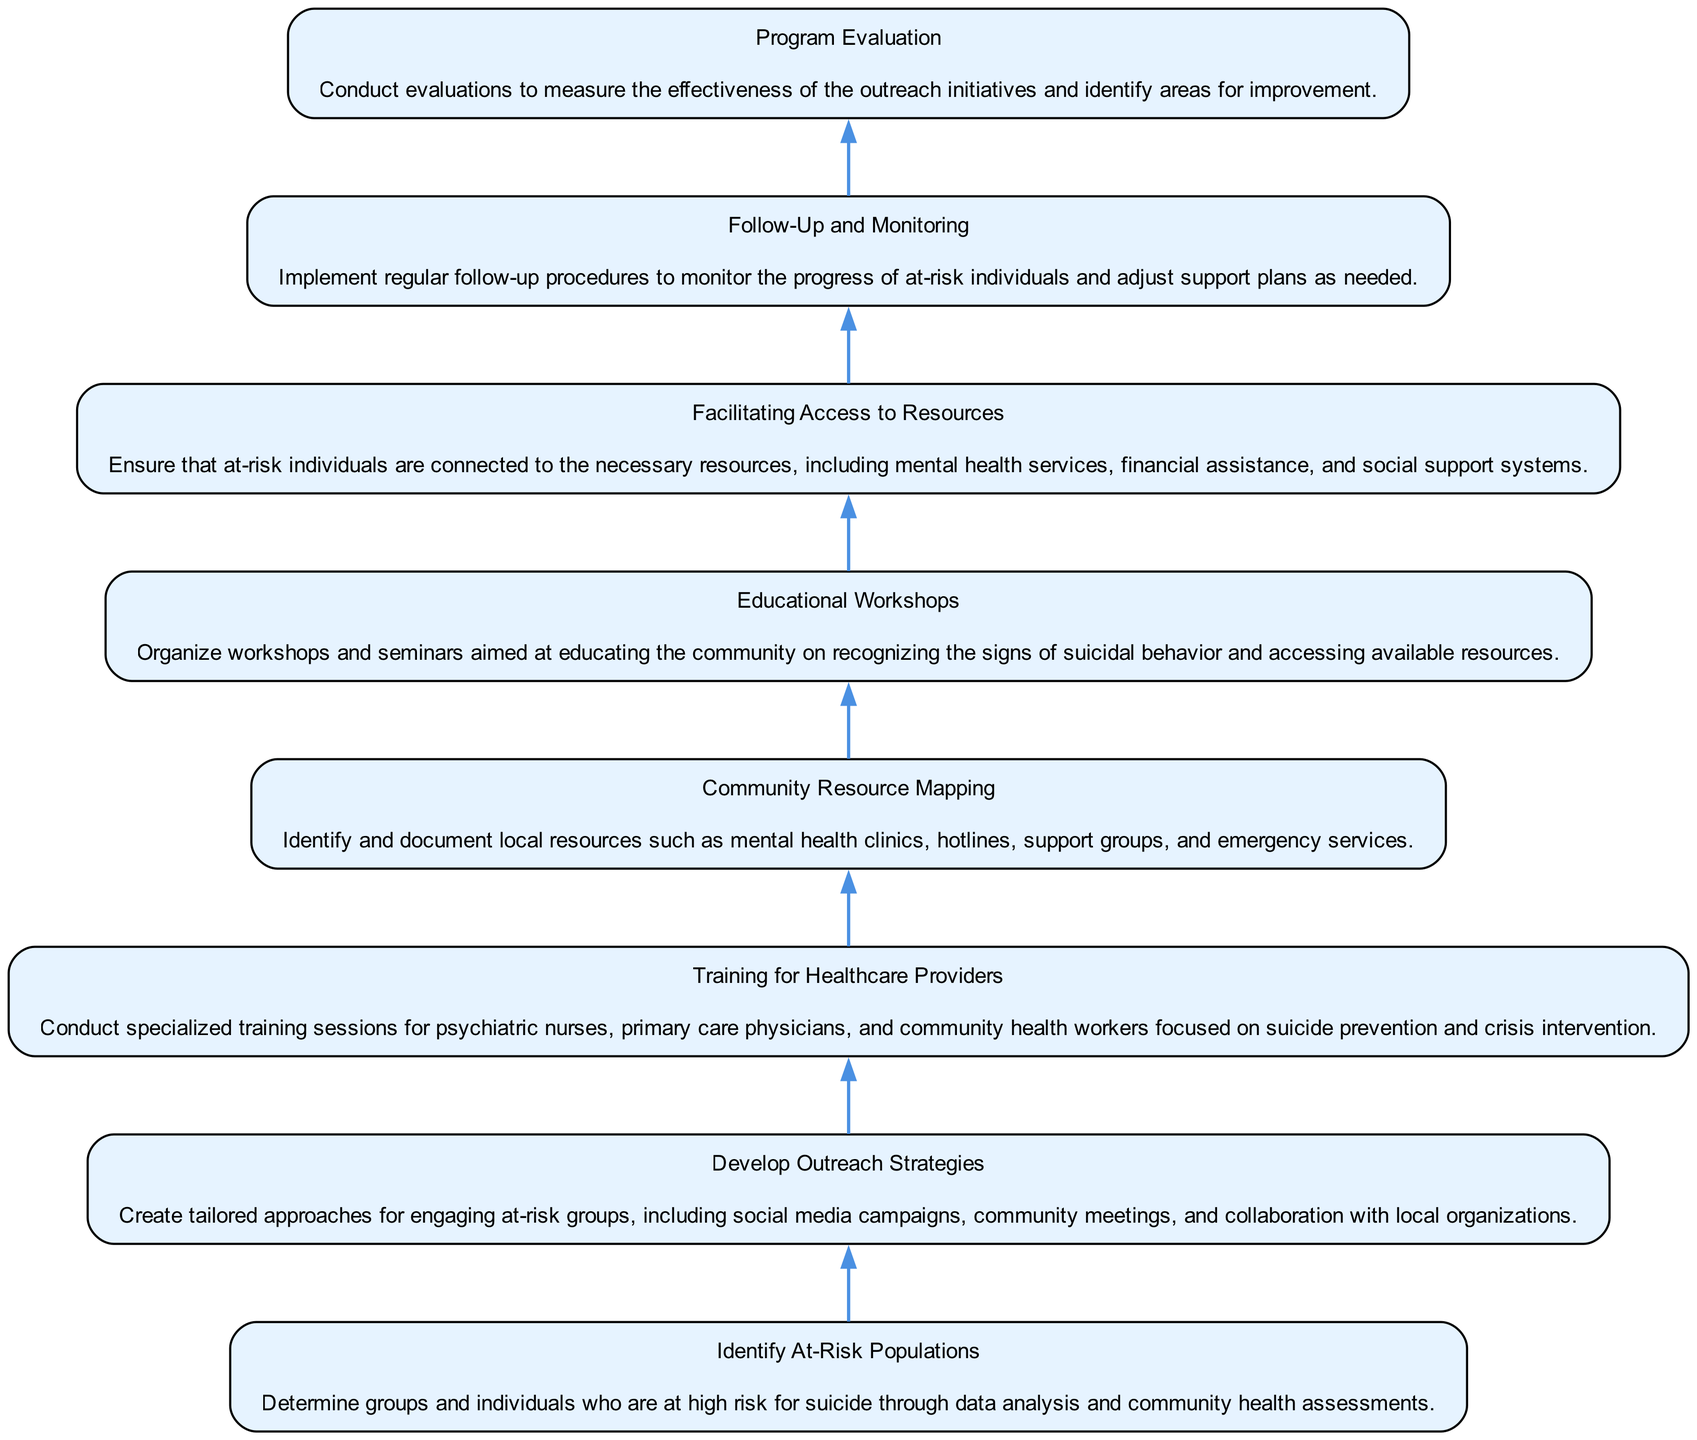What is the first step in the outreach program? The first step in the outreach program is "Identify At-Risk Populations," as it is the only node with no dependencies leading into it.
Answer: Identify At-Risk Populations How many nodes are in the diagram? By counting all the distinct steps from "Identify At-Risk Populations" to "Program Evaluation," we find there are eight nodes in total.
Answer: Eight What is the final node of the flowchart? The final node of the flowchart, which represents the last step in the outreach process, is "Program Evaluation."
Answer: Program Evaluation Which node depends on "Educational Workshops"? The node that depends on "Educational Workshops" is "Facilitating Access to Resources," meaning it cannot begin until the workshops are organized.
Answer: Facilitating Access to Resources What is the relationship between "Follow-Up and Monitoring" and "Program Evaluation"? "Program Evaluation" has a direct dependency on "Follow-Up and Monitoring," indicating that evaluations can only be conducted after monitoring the at-risk individuals' progress.
Answer: Follow-Up and Monitoring What happens after "Facilitating Access to Resources"? The next step after "Facilitating Access to Resources" is "Follow-Up and Monitoring," meaning that the organization must first connect individuals to resources before proceeding to follow-up activities.
Answer: Follow-Up and Monitoring How many dependencies does "Community Resource Mapping" have? "Community Resource Mapping" has one dependency; it relies on the completion of "Training for Healthcare Providers" before it can take place.
Answer: One What is required for "Training for Healthcare Providers" to happen? "Training for Healthcare Providers" requires the completion of "Develop Outreach Strategies," which needs to have been successfully implemented first.
Answer: Develop Outreach Strategies 